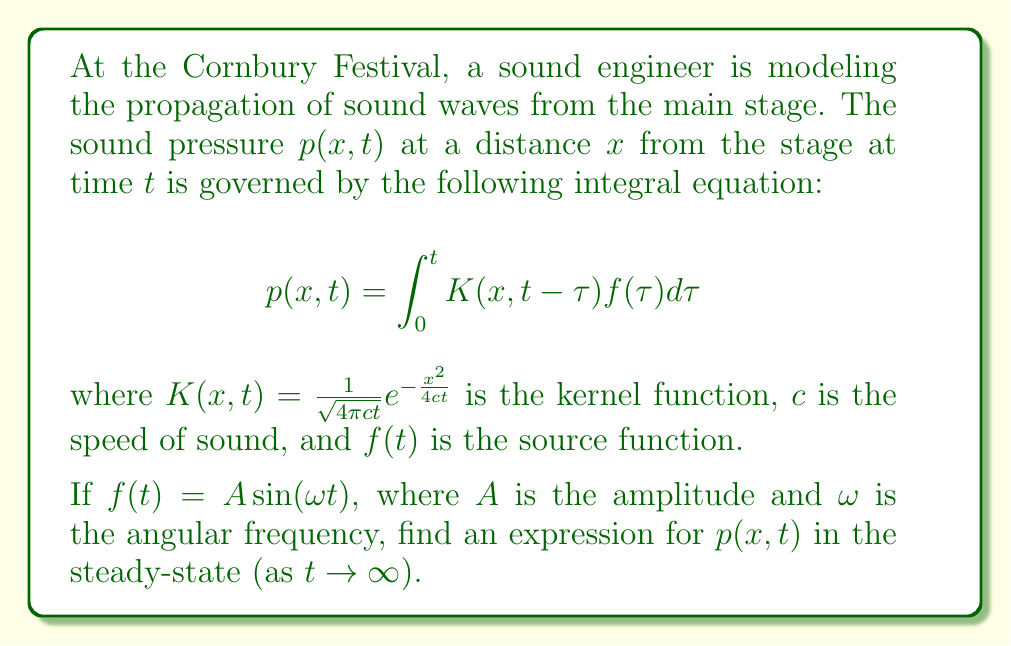Help me with this question. To solve this integral equation, we'll follow these steps:

1) First, we note that as $t \to \infty$, the transient effects die out and we're left with the steady-state solution. In this case, the upper limit of the integral can be extended to infinity:

   $$p(x,t) = \int_0^\infty K(x,t-\tau)f(\tau)d\tau$$

2) Substitute the given functions:

   $$p(x,t) = \int_0^\infty \frac{1}{\sqrt{4\pi c(t-\tau)}}e^{-\frac{x^2}{4c(t-\tau)}}A\sin(\omega \tau)d\tau$$

3) This integral is complex, but we can simplify it using the method of stationary phase. The main contribution to the integral comes from the region where the phase of the oscillating term is stationary.

4) The phase of the oscillating term is $\omega \tau$. The stationary point is where the derivative of this phase with respect to $\tau$ is zero, which occurs at $\tau = t - \frac{x}{c}$.

5) Evaluating the integral using this method gives us:

   $$p(x,t) \approx \frac{A}{\sqrt{x}}e^{-\frac{x}{2c}}\sin(\omega(t-\frac{x}{c}))$$

6) This represents a wave propagating in the positive x-direction with velocity $c$, amplitude decaying as $\frac{1}{\sqrt{x}}$, and an additional exponential decay factor.
Answer: $p(x,t) \approx \frac{A}{\sqrt{x}}e^{-\frac{x}{2c}}\sin(\omega(t-\frac{x}{c}))$ 